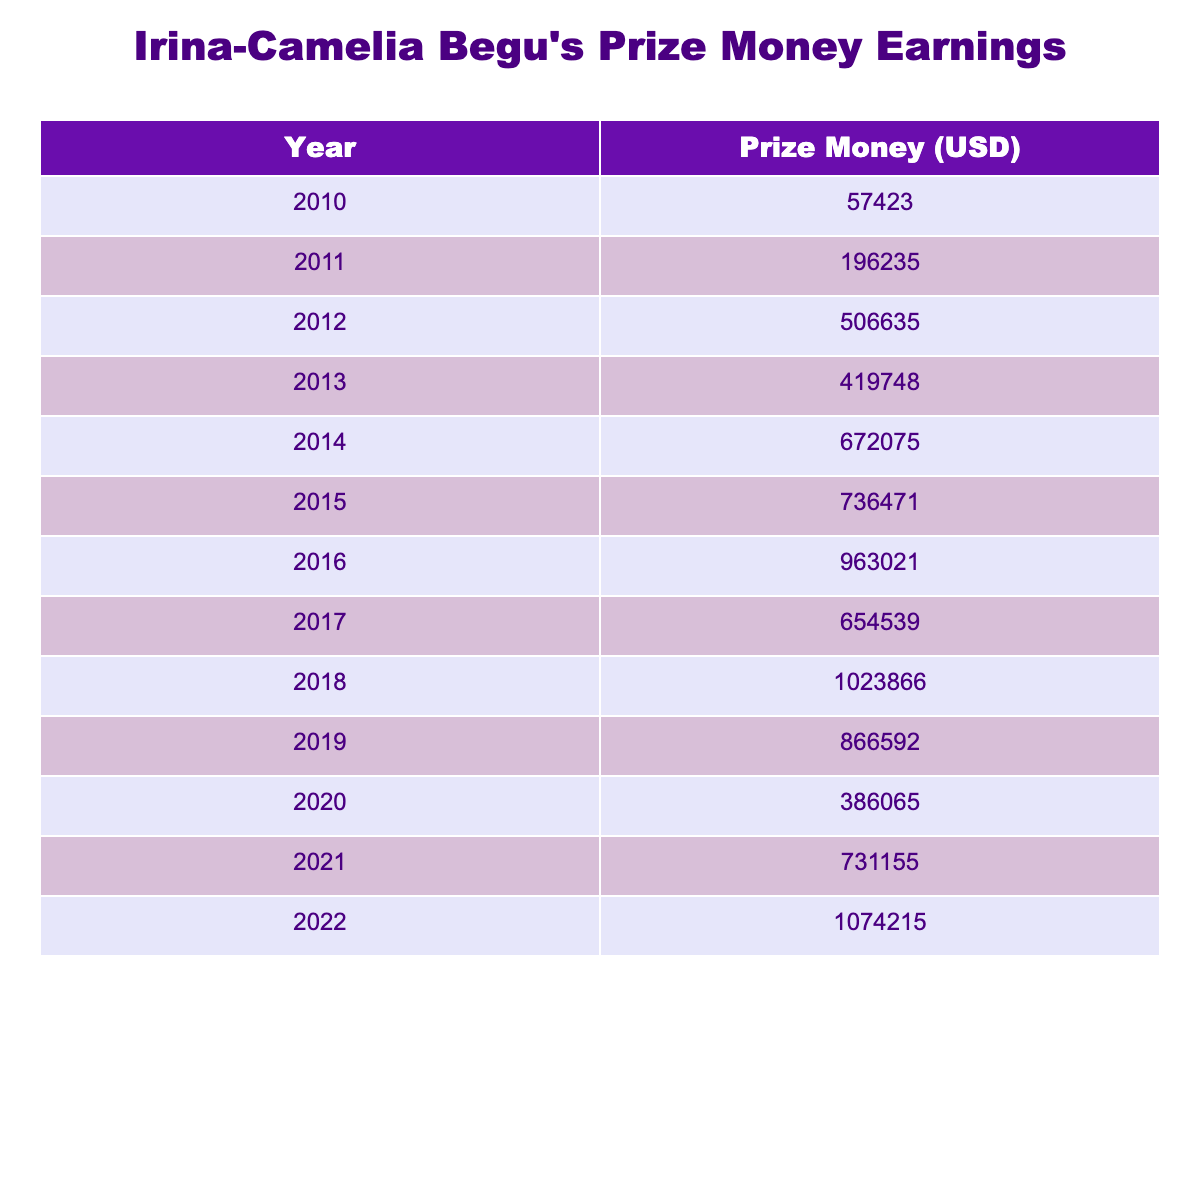What was Irina-Camelia Begu's highest prize money earning year? By inspecting the table, the maximum value listed in the 'Prize Money (USD)' column can be found, which shows that 2022 had the highest prize money of 1,074,215 USD.
Answer: 2022 What was the total prize money earned by Irina-Camelia Begu from 2010 to 2022? To find the total, we sum up all the values in the 'Prize Money (USD)' column: 57,423 + 196,235 + 506,635 + 419,748 + 672,075 + 736,471 + 963,021 + 654,539 + 1,023,866 + 866,592 + 386,065 + 731,155 + 1,074,215 = 6,185,085 USD.
Answer: 6,185,085 What was the prize money in 2015? The table directly indicates the amount listed for the year 2015 in the 'Prize Money (USD)' column, which is 736,471 USD.
Answer: 736,471 How much prize money did Irina-Camelia Begu earn in 2012 compared to 2013? Looking at the values for 2012 (506,635 USD) and 2013 (419,748 USD), we can see that the 2012 amount is greater; the difference is 506,635 - 419,748 = 86,887 USD, indicating she earned more in 2012.
Answer: She earned 86,887 USD more in 2012 What is the average prize money per year from 2010 to 2022? We have 13 years of data, so to find the average, we take the total prize money (6,185,085 USD) and divide it by 13, which gives us about 476,536.54 USD.
Answer: About 476,537 Did Irina-Camelia Begu earn more than 1 million USD in any year? Upon examining the table, we find that the only years with prize money above 1 million were 2018 (1,023,866 USD) and 2022 (1,074,215 USD). Therefore, the answer is yes.
Answer: Yes In which year did her prize money first cross 600,000 USD? By inspecting the table, we see that her earnings exceeded 600,000 USD in the year 2014 (672,075 USD). The previous years showed lower amounts, confirming 2014 was the first year over that threshold.
Answer: 2014 How did Irina-Camelia Begu's prize money earnings trend from 2010 to 2022? By analyzing the values over the years, we observe they generally increased, peaking in 2022. A notable spike occurs from 2014 onward, indicating an upward trend throughout the years.
Answer: The trend was generally increasing 